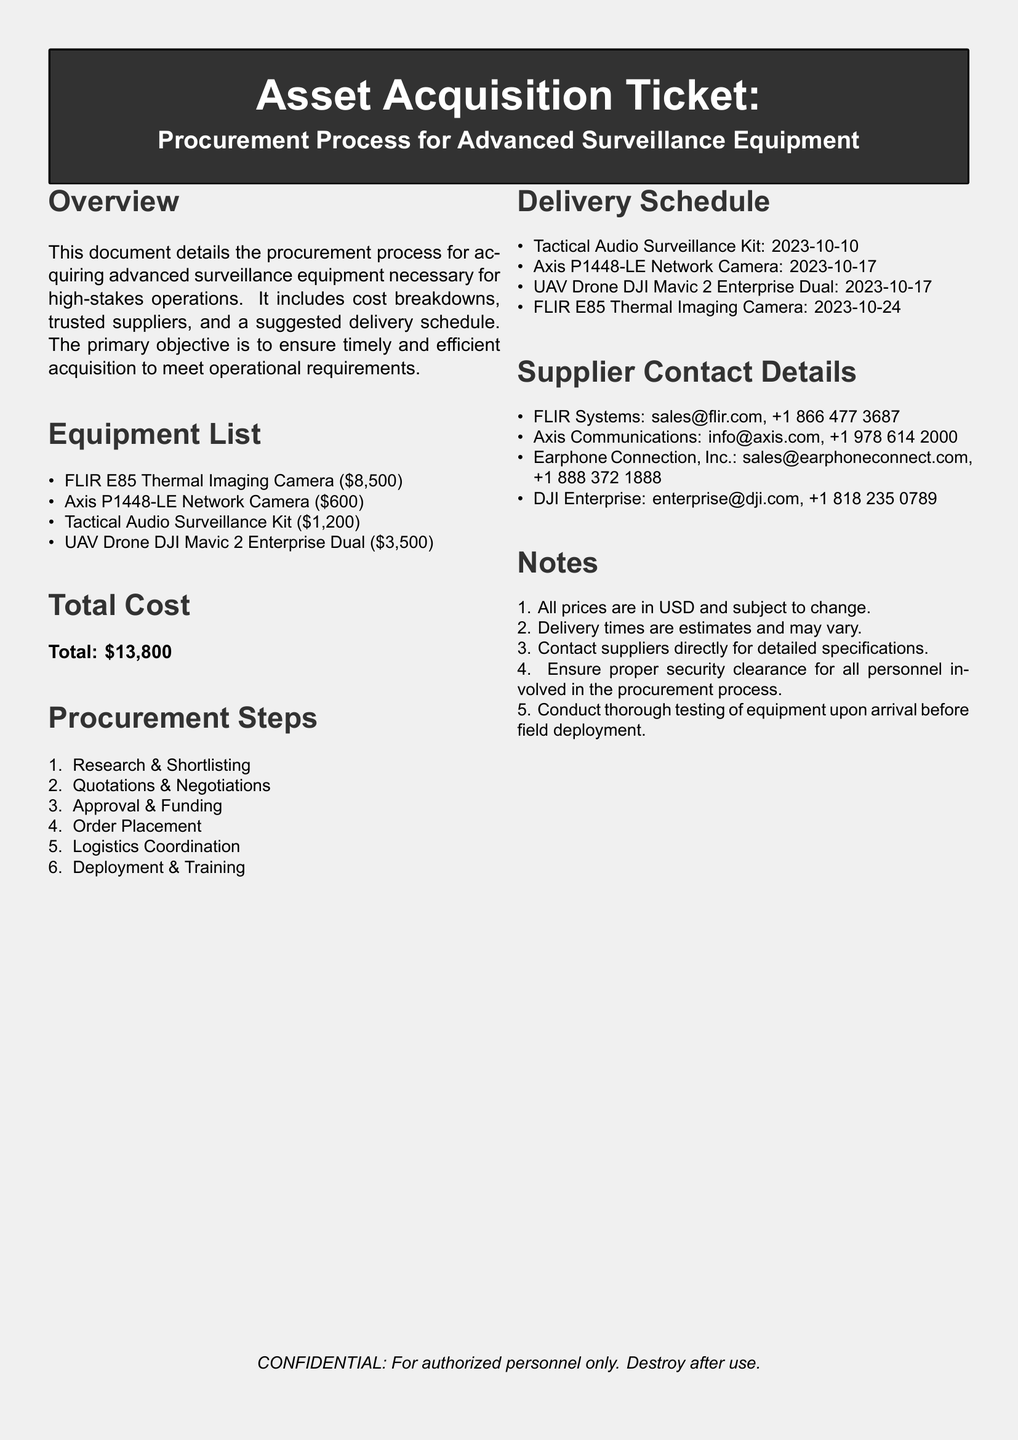What is the total cost of the equipment? The total cost is the sum of all listed equipment prices: $8,500 + $600 + $1,200 + $3,500 = $13,800.
Answer: $13,800 When is the delivery date for the UAV Drone? The delivery schedule indicates that the UAV Drone DJI Mavic 2 Enterprise Dual will be delivered on October 17, 2023.
Answer: 2023-10-17 Who is the supplier for the Thermal Imaging Camera? The document lists FLIR Systems as the supplier for the FLIR E85 Thermal Imaging Camera with contact details provided.
Answer: FLIR Systems What step comes after Order Placement in the procurement process? The steps are listed sequentially, with "Logistics Coordination" following "Order Placement."
Answer: Logistics Coordination How much does the Tactical Audio Surveillance Kit cost? The cost for the Tactical Audio Surveillance Kit is explicitly stated as $1,200 in the equipment list.
Answer: $1,200 What is the purpose of this document? The overview clearly states that the document details the procurement process for acquiring advanced surveillance equipment necessary for high-stakes operations.
Answer: Procurement process for advanced surveillance equipment What is the expected delivery date for the Axis P1448-LE Network Camera? The document specifies the delivery date for the Axis P1448-LE Network Camera as October 17, 2023.
Answer: 2023-10-17 Which supplier can be contacted for equipment specifications? The notes suggest contacting suppliers directly for detailed specifications, indicating general communication with any listed supplier.
Answer: Suppliers What document type is this? The title at the top of the document explicitly labels it as an "Asset Acquisition Ticket."
Answer: Asset Acquisition Ticket 